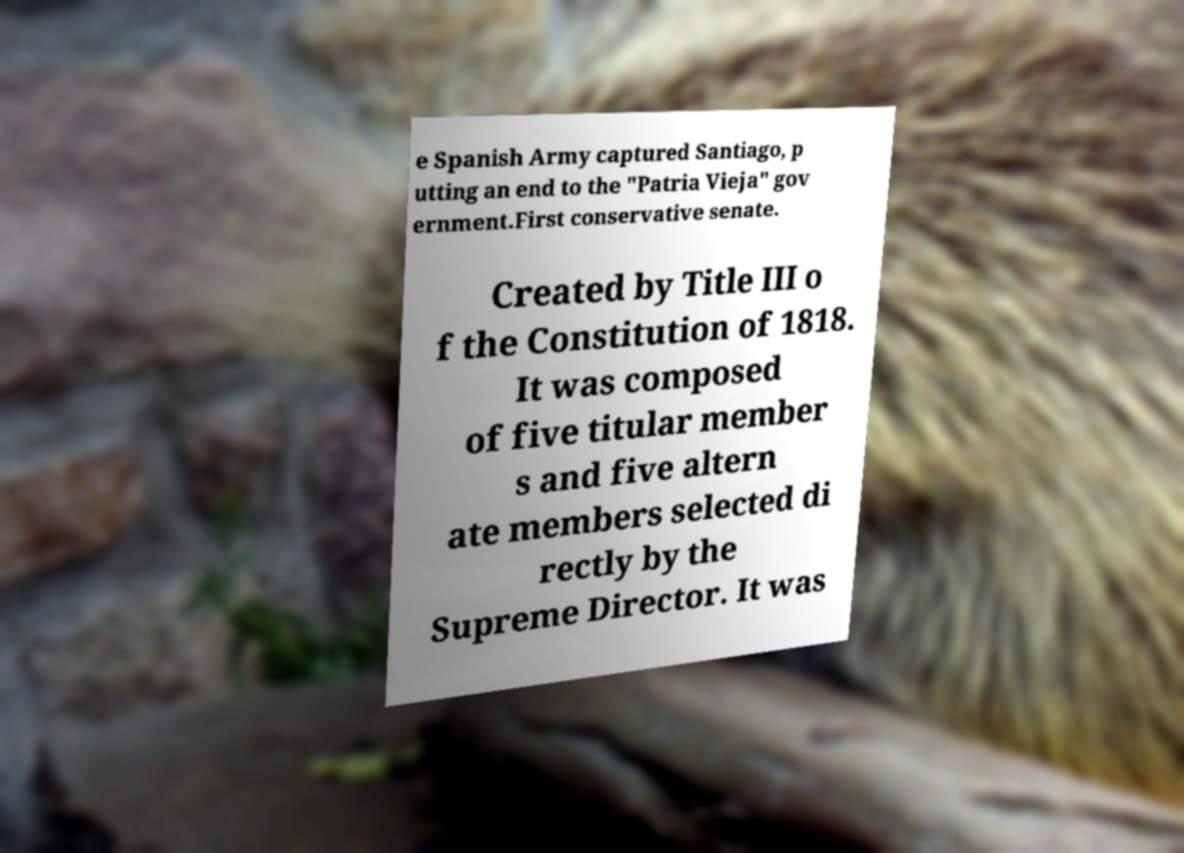What messages or text are displayed in this image? I need them in a readable, typed format. e Spanish Army captured Santiago, p utting an end to the "Patria Vieja" gov ernment.First conservative senate. Created by Title III o f the Constitution of 1818. It was composed of five titular member s and five altern ate members selected di rectly by the Supreme Director. It was 